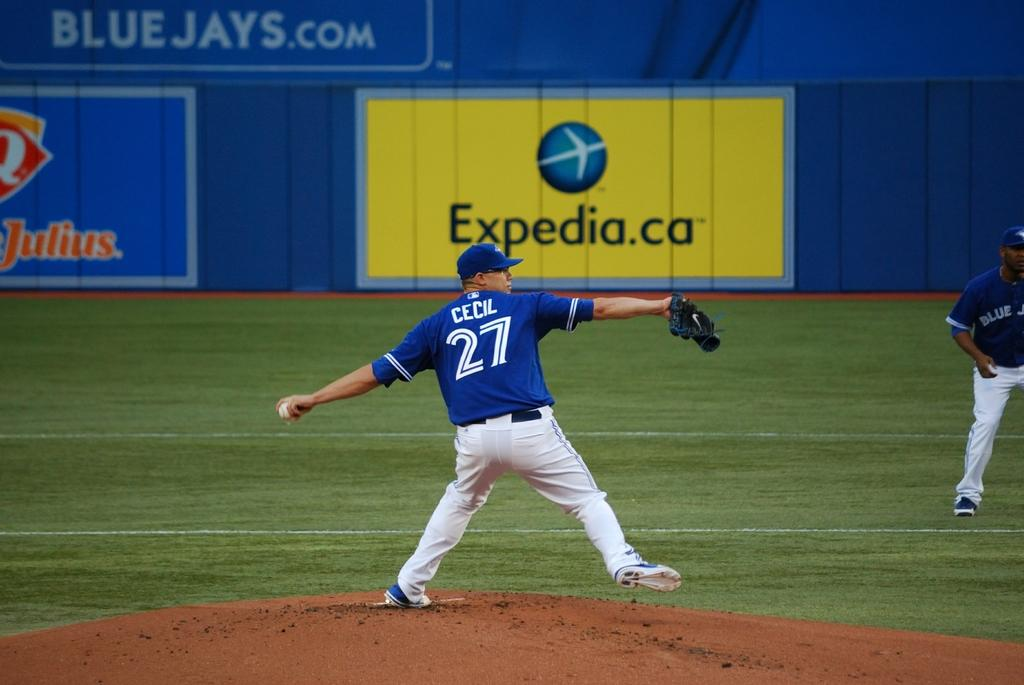<image>
Relay a brief, clear account of the picture shown. Cecil in the 27 jersey is about to throw the baseball. 